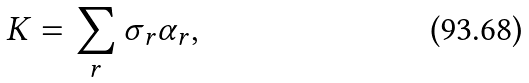<formula> <loc_0><loc_0><loc_500><loc_500>K = \sum _ { r } \sigma _ { r } \alpha _ { r } ,</formula> 